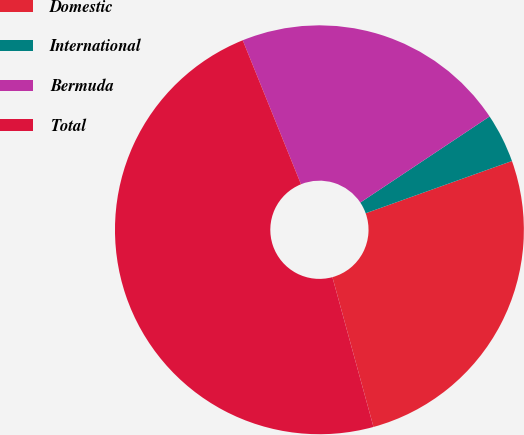Convert chart. <chart><loc_0><loc_0><loc_500><loc_500><pie_chart><fcel>Domestic<fcel>International<fcel>Bermuda<fcel>Total<nl><fcel>26.2%<fcel>3.89%<fcel>21.77%<fcel>48.14%<nl></chart> 